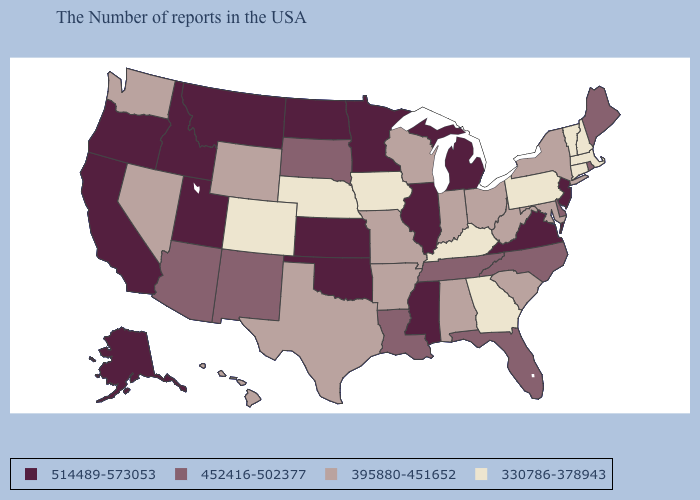Name the states that have a value in the range 395880-451652?
Keep it brief. New York, Maryland, South Carolina, West Virginia, Ohio, Indiana, Alabama, Wisconsin, Missouri, Arkansas, Texas, Wyoming, Nevada, Washington, Hawaii. What is the lowest value in the Northeast?
Be succinct. 330786-378943. What is the value of Utah?
Concise answer only. 514489-573053. How many symbols are there in the legend?
Be succinct. 4. Does New Jersey have the lowest value in the Northeast?
Keep it brief. No. What is the value of Wisconsin?
Short answer required. 395880-451652. Name the states that have a value in the range 514489-573053?
Answer briefly. New Jersey, Virginia, Michigan, Illinois, Mississippi, Minnesota, Kansas, Oklahoma, North Dakota, Utah, Montana, Idaho, California, Oregon, Alaska. Name the states that have a value in the range 395880-451652?
Write a very short answer. New York, Maryland, South Carolina, West Virginia, Ohio, Indiana, Alabama, Wisconsin, Missouri, Arkansas, Texas, Wyoming, Nevada, Washington, Hawaii. What is the value of Minnesota?
Answer briefly. 514489-573053. What is the lowest value in the Northeast?
Short answer required. 330786-378943. What is the lowest value in states that border Mississippi?
Be succinct. 395880-451652. What is the value of Utah?
Give a very brief answer. 514489-573053. Does Oregon have the lowest value in the USA?
Answer briefly. No. What is the highest value in states that border Pennsylvania?
Short answer required. 514489-573053. Does the first symbol in the legend represent the smallest category?
Write a very short answer. No. 